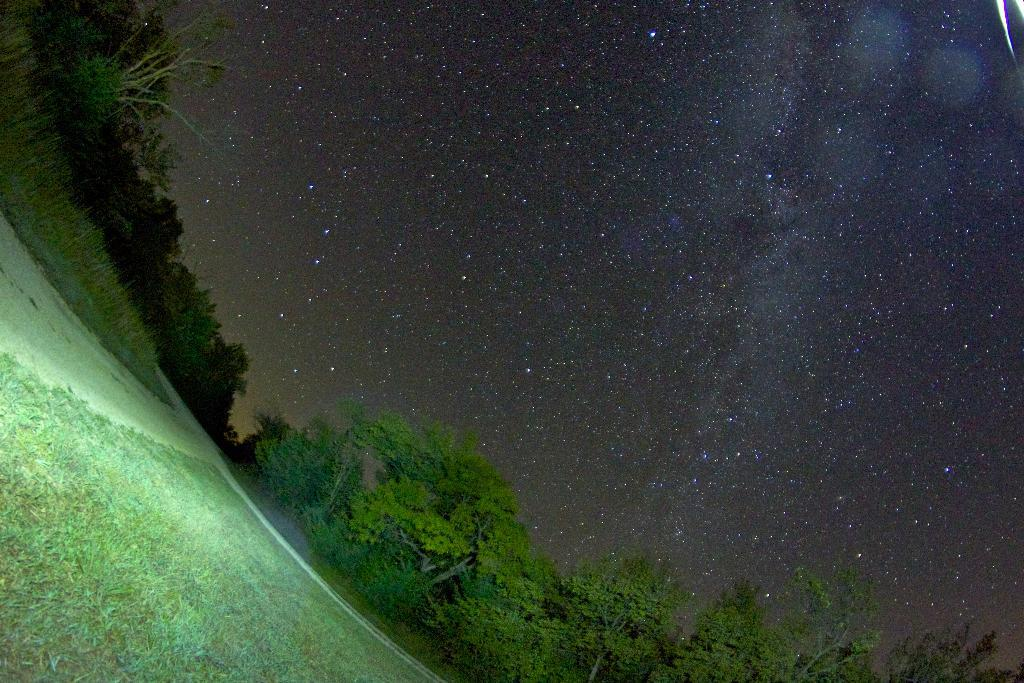What can be seen in the image that people might walk on? There is a path in the image that people might walk on. What type of vegetation is present in the image? There is a group of trees in the image. What is visible in the background of the image? The sky is visible in the background of the image. Where is the mine located in the image? There is no mine present in the image. What type of plants can be seen growing on the path in the image? There is no mention of plants growing on the path in the image; only a path and a group of trees are present. 